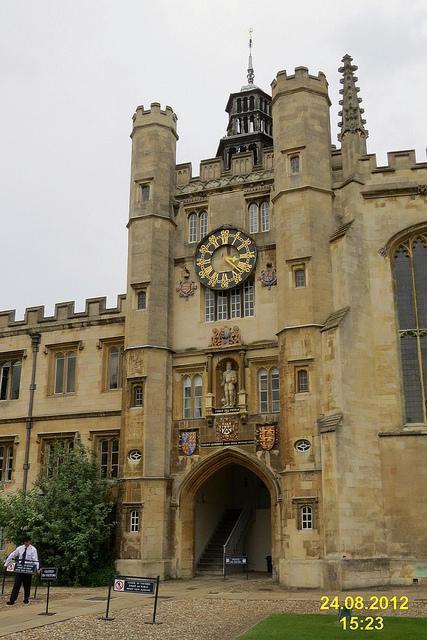What is the person on the left wearing?
From the following four choices, select the correct answer to address the question.
Options: Tie, scarf, cowboy hat, suspenders. Tie. 